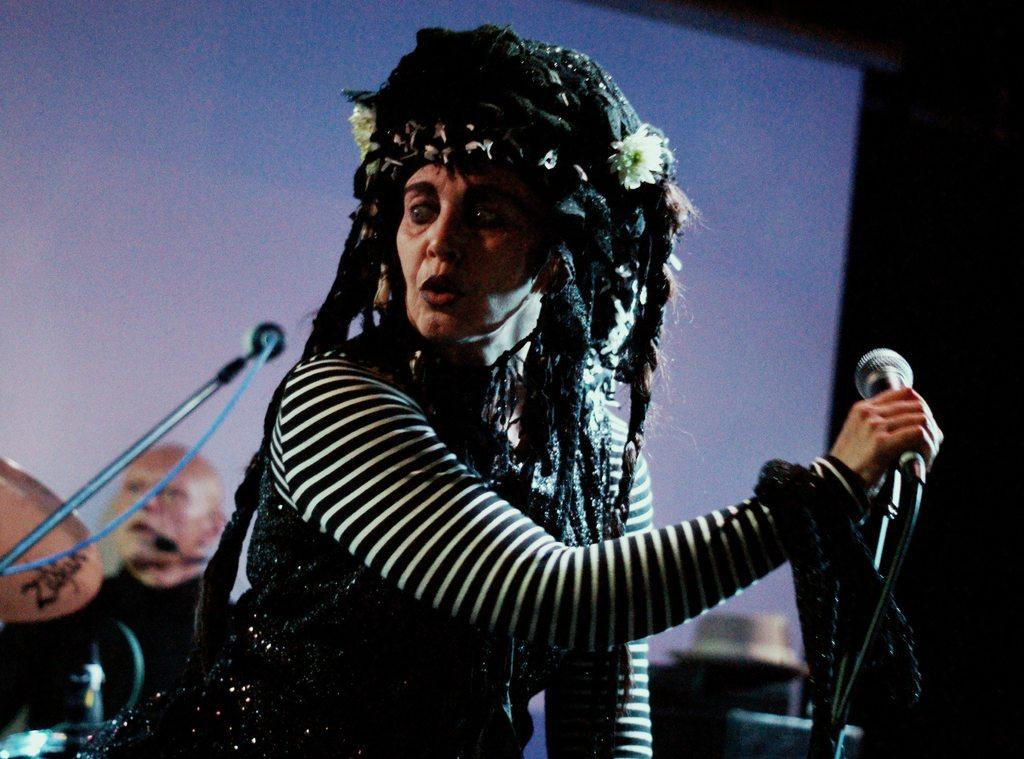What is the woman in the image wearing? The woman in the image is wearing a black dress. What is the woman holding in the image? The woman is holding a microphone. What is the microphone attached to in the image? The microphone has a holder. What is the person in the image wearing? The person in the image is wearing a black t-shirt. What color is the background of the image? The background of the image is blue. What is the woman's wealth status in the image? There is no information about the woman's wealth status in the image. What achievements has the person in the black t-shirt accomplished, as seen in the image? There is no information about the person's achievements in the image. 